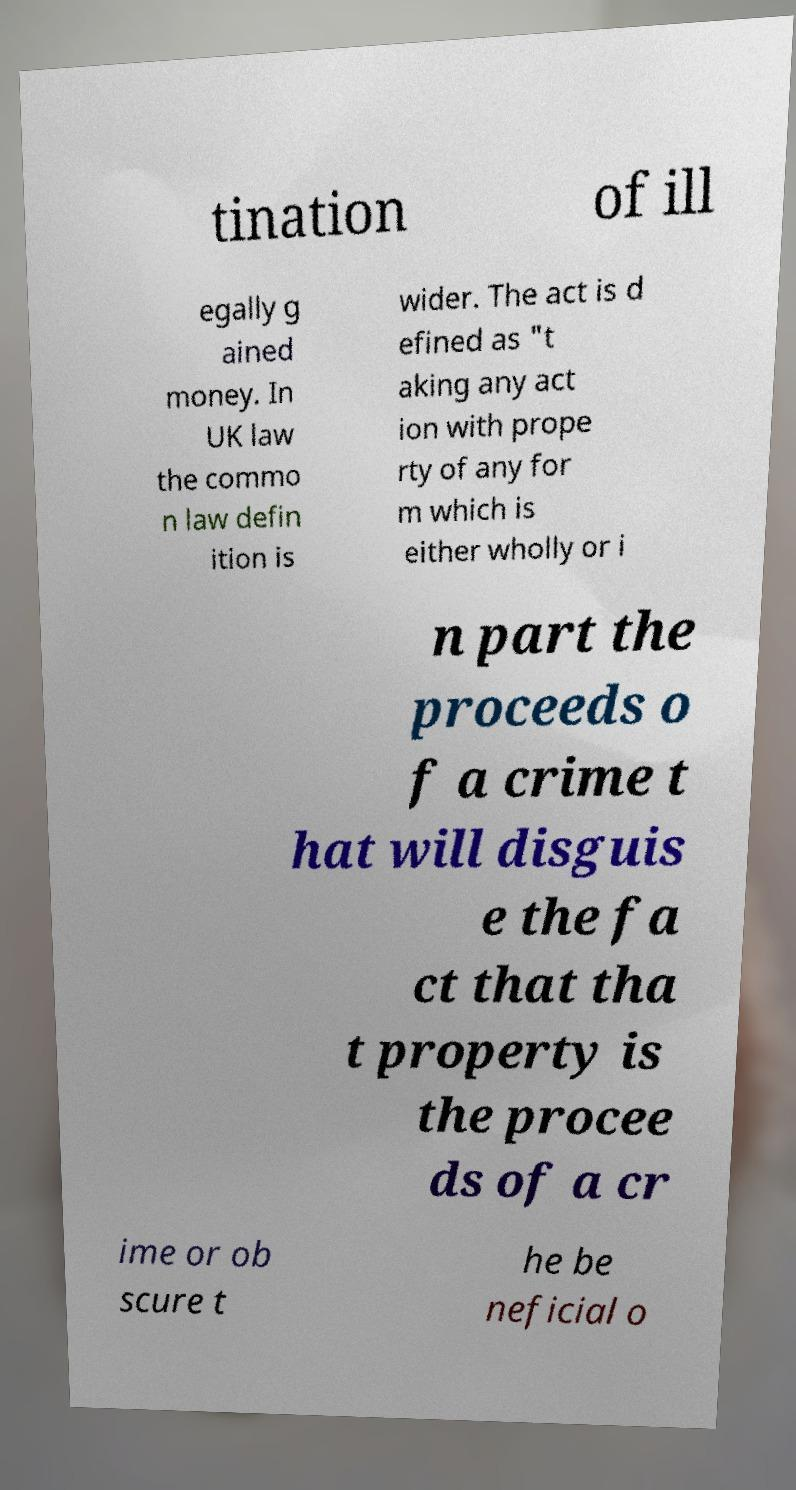I need the written content from this picture converted into text. Can you do that? tination of ill egally g ained money. In UK law the commo n law defin ition is wider. The act is d efined as "t aking any act ion with prope rty of any for m which is either wholly or i n part the proceeds o f a crime t hat will disguis e the fa ct that tha t property is the procee ds of a cr ime or ob scure t he be neficial o 